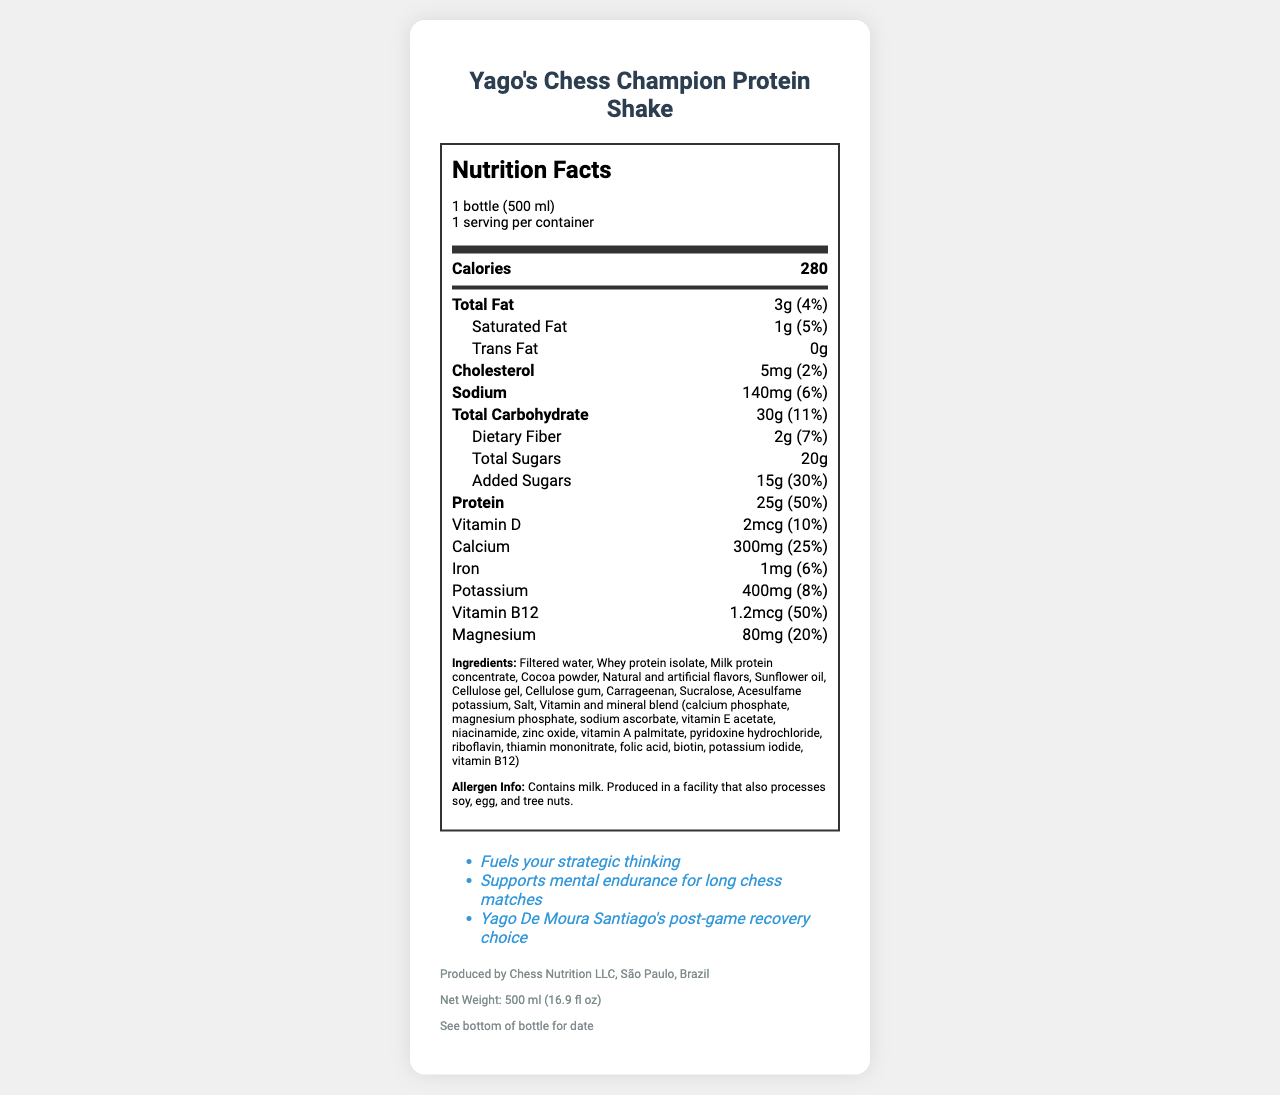what is the serving size of Yago's Chess Champion Protein Shake? The serving size information is listed in the "servingSize" field: "1 bottle (500 ml)".
Answer: 1 bottle (500 ml) how many calories does one serving contain? The calories per serving are shown in the main section of the nutrition label: "Calories 280".
Answer: 280 what is the total protein amount per serving? The total amount of protein per serving is provided in the document: "Protein: 25g (50%)".
Answer: 25g how much calcium does one serving offer? The calcium content per serving is specified in the nutrition facts: "Calcium: 300mg (25%)".
Answer: 300mg what allergens are contained in the protein shake? The allergen information is detailed under the allergen section: "Contains milk. Produced in a facility that also processes soy, egg, and tree nuts."
Answer: Contains milk. Produced in a facility that also processes soy, egg, and tree nuts. which nutrient has the highest daily value percentage? 
    A. Total Fat
    B. Protein
    C. Vitamin D
    D. Potassium Protein has the highest daily value percentage at 50%, as compared to other nutrients listed.
Answer: B. Protein how many grams of added sugars are there in one serving?
    i. 10g
    ii. 15g
    iii. 20g
    iv. 25g The document specifies that the added sugars amount to "15g (30%)".
Answer: ii. 15g is this product suitable for someone with a soy allergy? The allergen information states: "Produced in a facility that also processes soy," which means there is a risk of cross-contamination.
Answer: No can you use this product after the 'best before' date? The document mentions "Best Before: See bottom of bottle for date," implying it's best consumed before that date for quality assurance.
Answer: Not recommended summarize the main features and nutritional value of Yago's Chess Champion Protein Shake. The product details and nutritional value highlight its benefits for post-game recovery, nutritional content, and information related to allergens and best consumption date.
Answer: Yago's Chess Champion Protein Shake is a protein-rich drink, ideal for post-game recovery, inspired by Yago De Moura Santiago. Each 500 ml bottle provides 280 calories, 25g of protein, and essential vitamins and minerals such as calcium, iron, potassium, and magnesium. It supports mental endurance for long chess matches, and fueling strategic thinking. The shake contains milk and is produced in a facility that processes soy, egg, and tree nuts. what is the ratio of total sugars to added sugars in the drink? While the document lists the amounts for total sugars (20g) and added sugars (15g), it does not provide a relationship that defines a clear ratio.
Answer: The ratio cannot be determined what % daily value of fiber does the drink contain? The daily value percentage for dietary fiber is given in the document: "Dietary Fiber: 2g (7%)".
Answer: 7% how much vitamin B12 does the protein shake provide? The vitamin B12 content is mentioned in the nutrition facts: "Vitamin B12: 1.2mcg (50%)".
Answer: 1.2mcg 